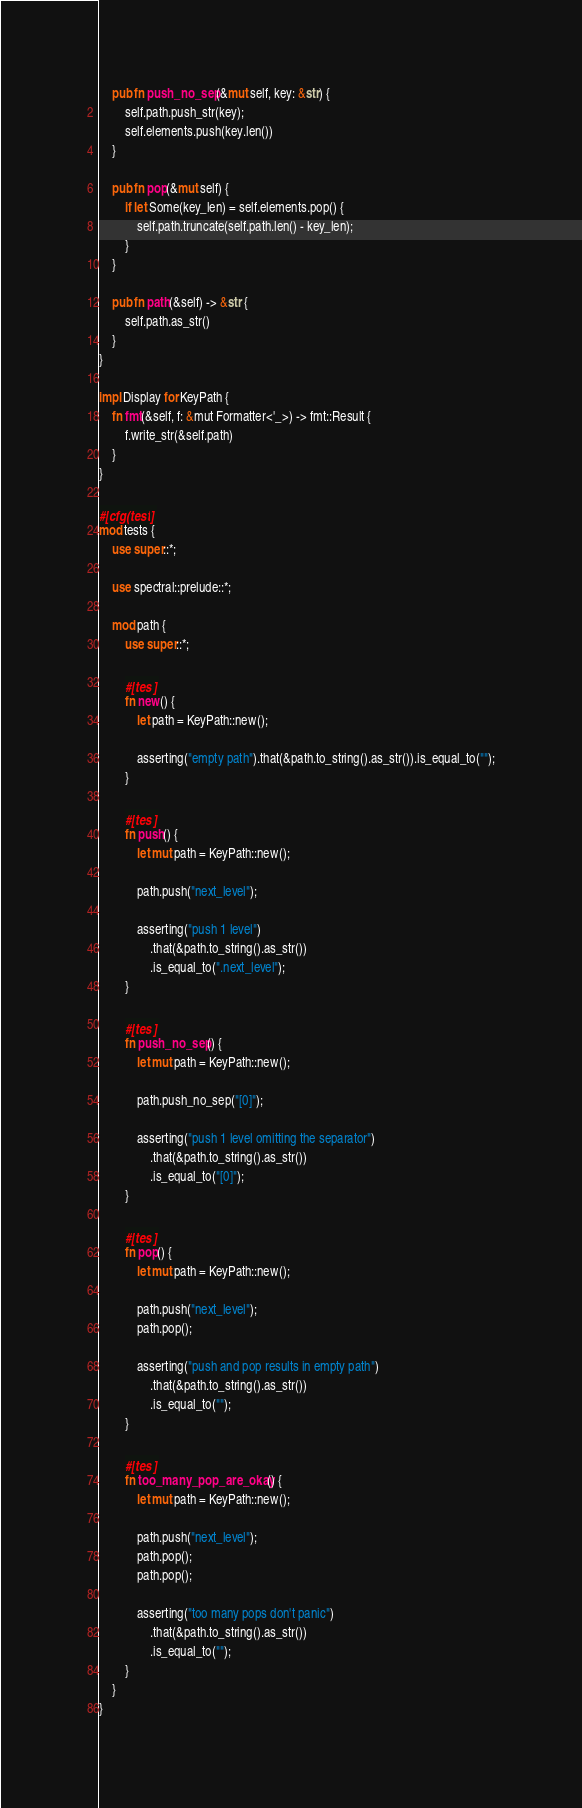Convert code to text. <code><loc_0><loc_0><loc_500><loc_500><_Rust_>    pub fn push_no_sep(&mut self, key: &str) {
        self.path.push_str(key);
        self.elements.push(key.len())
    }

    pub fn pop(&mut self) {
        if let Some(key_len) = self.elements.pop() {
            self.path.truncate(self.path.len() - key_len);
        }
    }

    pub fn path(&self) -> &str {
        self.path.as_str()
    }
}

impl Display for KeyPath {
    fn fmt(&self, f: &mut Formatter<'_>) -> fmt::Result {
        f.write_str(&self.path)
    }
}

#[cfg(test)]
mod tests {
    use super::*;

    use spectral::prelude::*;

    mod path {
        use super::*;

        #[test]
        fn new() {
            let path = KeyPath::new();

            asserting("empty path").that(&path.to_string().as_str()).is_equal_to("");
        }

        #[test]
        fn push() {
            let mut path = KeyPath::new();

            path.push("next_level");

            asserting("push 1 level")
                .that(&path.to_string().as_str())
                .is_equal_to(".next_level");
        }

        #[test]
        fn push_no_sep() {
            let mut path = KeyPath::new();

            path.push_no_sep("[0]");

            asserting("push 1 level omitting the separator")
                .that(&path.to_string().as_str())
                .is_equal_to("[0]");
        }

        #[test]
        fn pop() {
            let mut path = KeyPath::new();

            path.push("next_level");
            path.pop();

            asserting("push and pop results in empty path")
                .that(&path.to_string().as_str())
                .is_equal_to("");
        }

        #[test]
        fn too_many_pop_are_okay() {
            let mut path = KeyPath::new();

            path.push("next_level");
            path.pop();
            path.pop();

            asserting("too many pops don't panic")
                .that(&path.to_string().as_str())
                .is_equal_to("");
        }
    }
}
</code> 